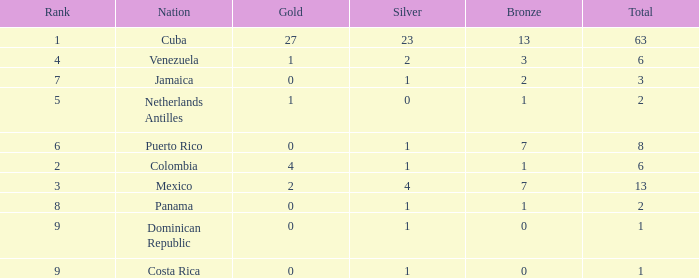What nation has the lowest gold average that has a rank over 9? None. 